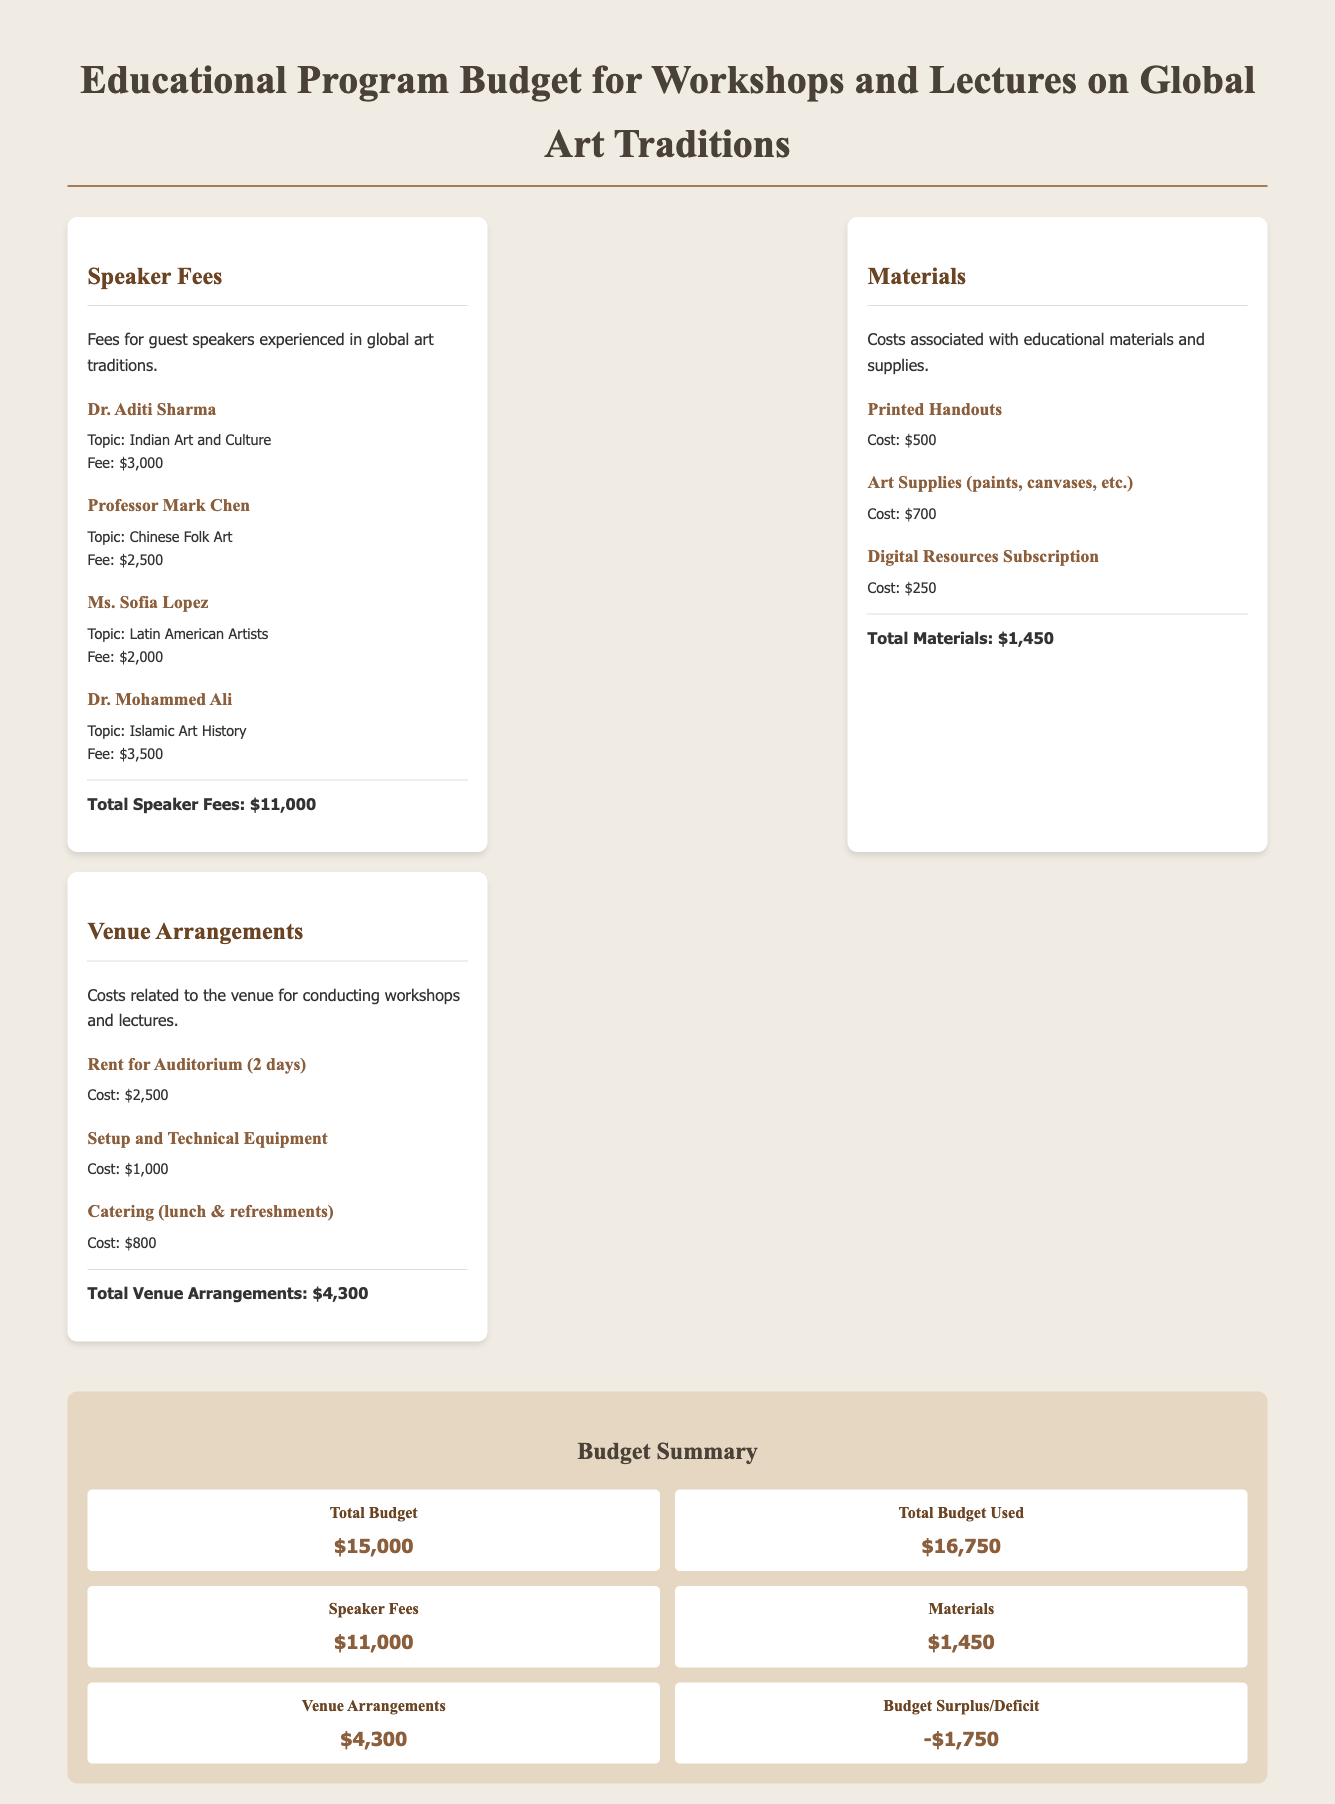What is the total speaker fee for Dr. Mohammed Ali? The fee for Dr. Mohammed Ali is listed as $3,500 in the document.
Answer: $3,500 What is the cost for printed handouts? The document specifies that the cost for printed handouts is $500.
Answer: $500 How much is allocated for art supplies? The document shows that the cost for art supplies is $700.
Answer: $700 What is the total cost for venue arrangements? The total costs for venue arrangements are aggregated to $4,300 in the budget.
Answer: $4,300 Who is the speaker discussing Latin American artists? Ms. Sofia Lopez is the speaker discussing Latin American artists as noted in the document.
Answer: Ms. Sofia Lopez What is the total budget used for the program? The document states that the total budget used is $16,750.
Answer: $16,750 What is the budget surplus or deficit? The summary mentions a budget deficit of $1,750.
Answer: -$1,750 How much is spent on catering? Catering costs are indicated in the document as $800.
Answer: $800 What are the costs associated with the digital resources subscription? The document lists the cost associated with the digital resources subscription as $250.
Answer: $250 